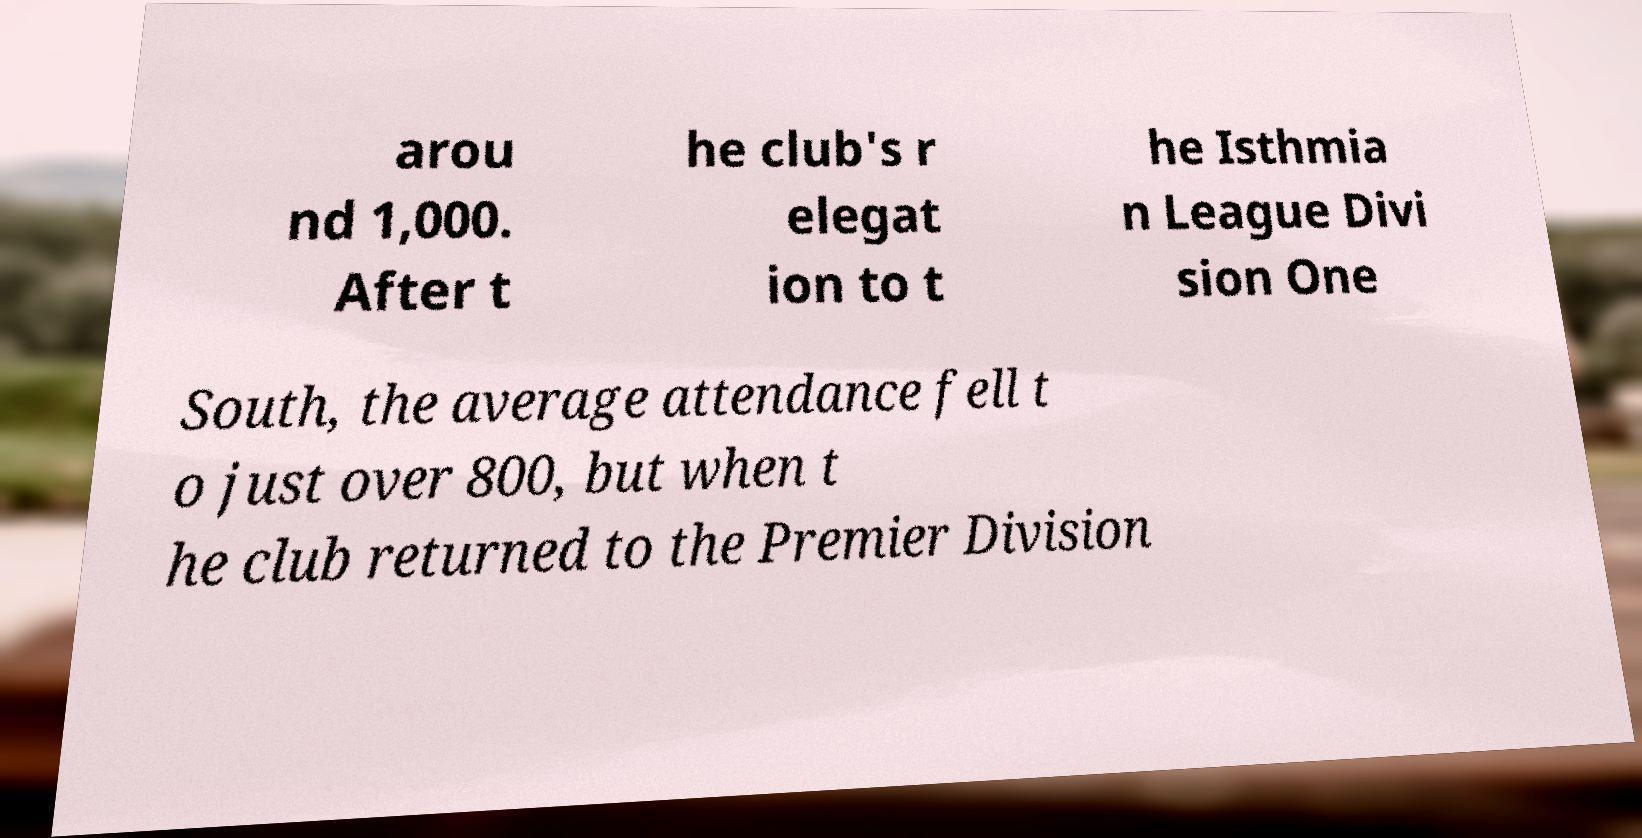Please identify and transcribe the text found in this image. arou nd 1,000. After t he club's r elegat ion to t he Isthmia n League Divi sion One South, the average attendance fell t o just over 800, but when t he club returned to the Premier Division 